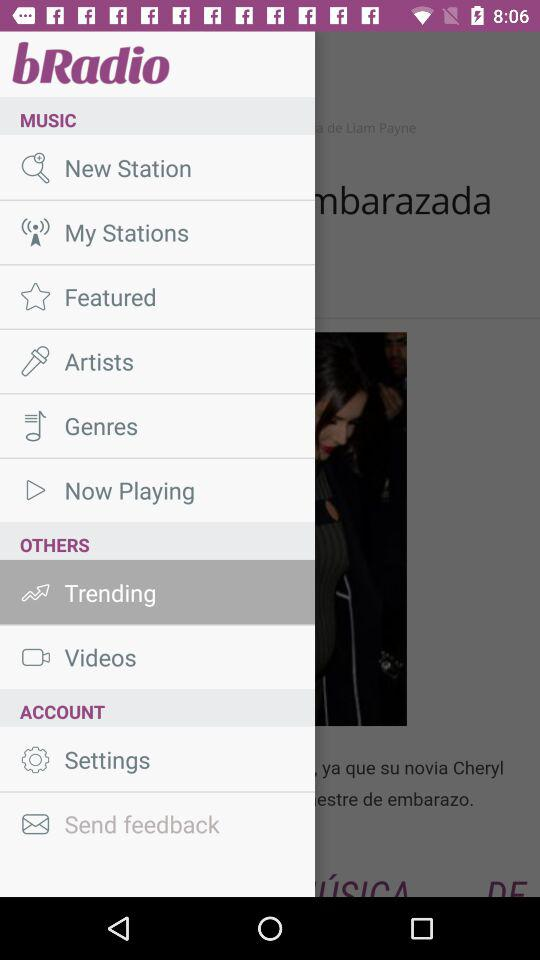Which item is selected? The selected item is "Trending". 